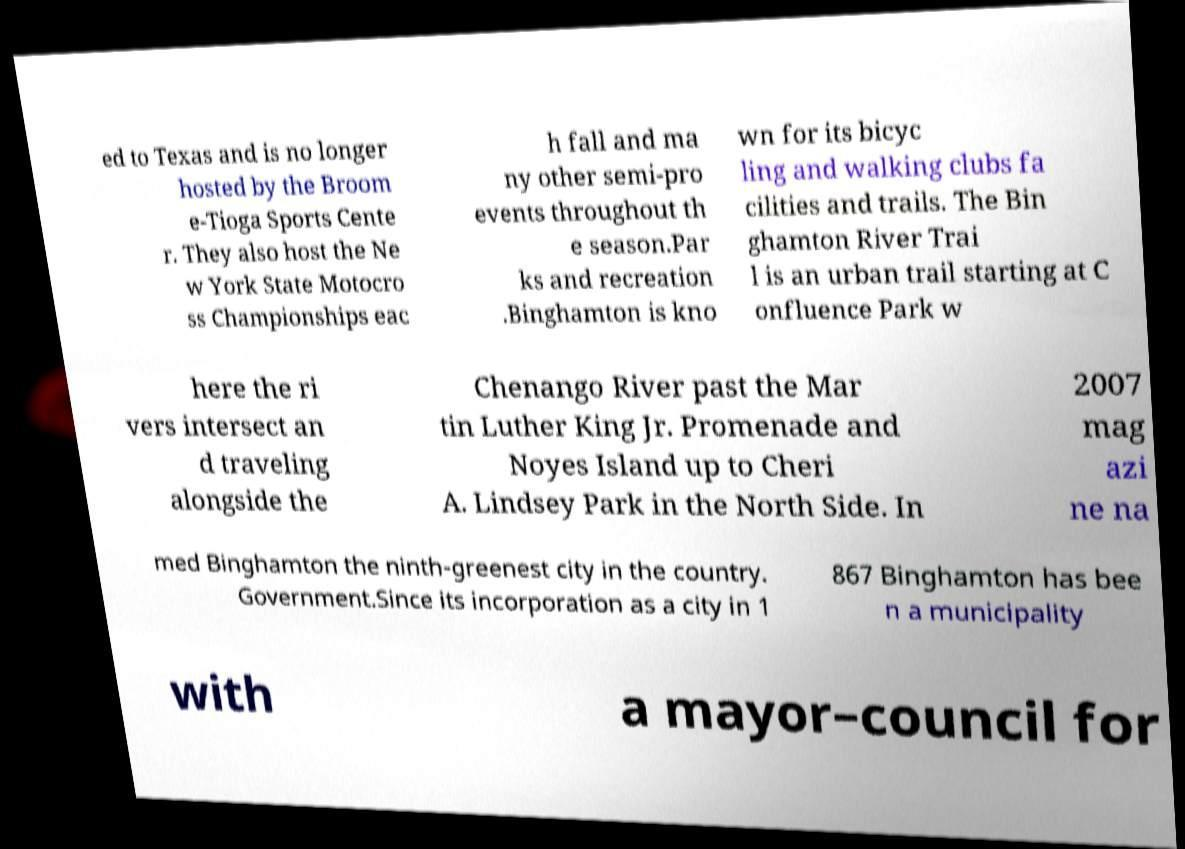For documentation purposes, I need the text within this image transcribed. Could you provide that? ed to Texas and is no longer hosted by the Broom e-Tioga Sports Cente r. They also host the Ne w York State Motocro ss Championships eac h fall and ma ny other semi-pro events throughout th e season.Par ks and recreation .Binghamton is kno wn for its bicyc ling and walking clubs fa cilities and trails. The Bin ghamton River Trai l is an urban trail starting at C onfluence Park w here the ri vers intersect an d traveling alongside the Chenango River past the Mar tin Luther King Jr. Promenade and Noyes Island up to Cheri A. Lindsey Park in the North Side. In 2007 mag azi ne na med Binghamton the ninth-greenest city in the country. Government.Since its incorporation as a city in 1 867 Binghamton has bee n a municipality with a mayor–council for 